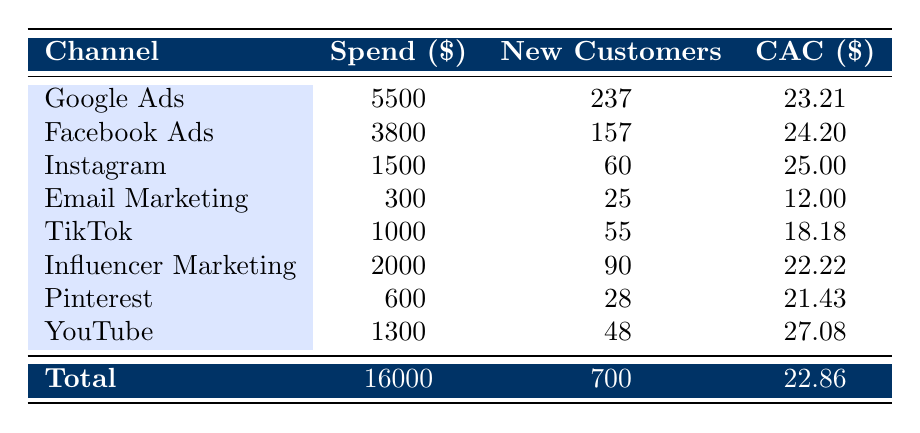What is the total spend on Google Ads in 2022? The total spend on Google Ads is found in the table under the "Spend" column for the Google Ads row, which shows \$5500.
Answer: 5500 How many new customers were acquired through Facebook Ads? The total number of new customers acquired via Facebook Ads is located in the "New Customers" column for the Facebook Ads row, which states 157.
Answer: 157 What is the Customer Acquisition Cost (CAC) for Email Marketing? The CAC for Email Marketing can be found in the corresponding row, which shows \$12.00 under the CAC column.
Answer: 12.00 Which channel had the highest CAC and what was that value? We compare all CAC values from each channel. The highest CAC is \$27.08 for YouTube. The comparison reveals this channel as having the highest cost per acquisition.
Answer: YouTube, 27.08 What is the average CAC across all channels? To find the average CAC, sum all CACs (23.21 + 24.20 + 25.00 + 12.00 + 18.18 + 22.22 + 21.43 + 27.08 =  160.32) and divide by the number of channels (8). The average CAC is 160.32 / 8 = 20.04.
Answer: 20.04 Did Instagram acquire more than 50 new customers? Looking at the data for Instagram, it shows 60 new customers acquired. Since 60 is greater than 50, the statement is true.
Answer: Yes Which marketing channel contributed the least to customer acquisition costs in terms of total spending? Analyzing the spend for each channel reveals that Email Marketing spent \$300, which is the lowest in the "Spend" column.
Answer: Email Marketing What was the total number of new customers acquired from all channels combined? To determine the total, we sum the new customers across all channels (237 + 157 + 60 + 25 + 55 + 90 + 28 + 48 = 700). Thus, the total is 700 new customers.
Answer: 700 Is it true that Influencer Marketing had a lower CAC than Facebook Ads? We see that Influencer Marketing has a CAC of \$22.22 while Facebook Ads is at \$24.20. Since \$22.22 is less than \$24.20, the statement is true.
Answer: Yes 